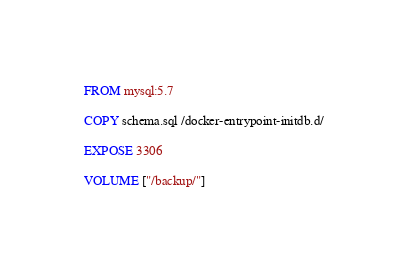Convert code to text. <code><loc_0><loc_0><loc_500><loc_500><_Dockerfile_>FROM mysql:5.7

COPY schema.sql /docker-entrypoint-initdb.d/

EXPOSE 3306

VOLUME ["/backup/"]
</code> 